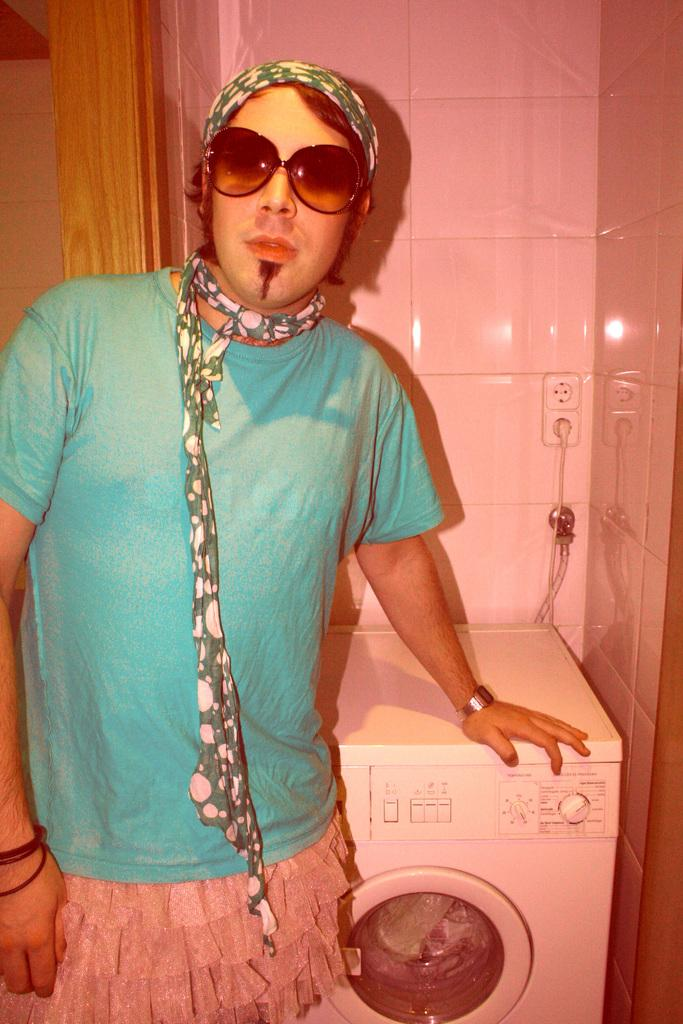Who or what is the main subject in the image? There is a person in the image. What object is located behind the person? There is a washing machine behind the person. What can be seen on the wall in the background of the image? There are switch boards on the wall in the background of the image. Is there a carriage visible in the image? No, there is no carriage present in the image. Can you describe the person's thoughts while looking at the switch boards? The image does not provide information about the person's thoughts, so it cannot be determined from the image. 